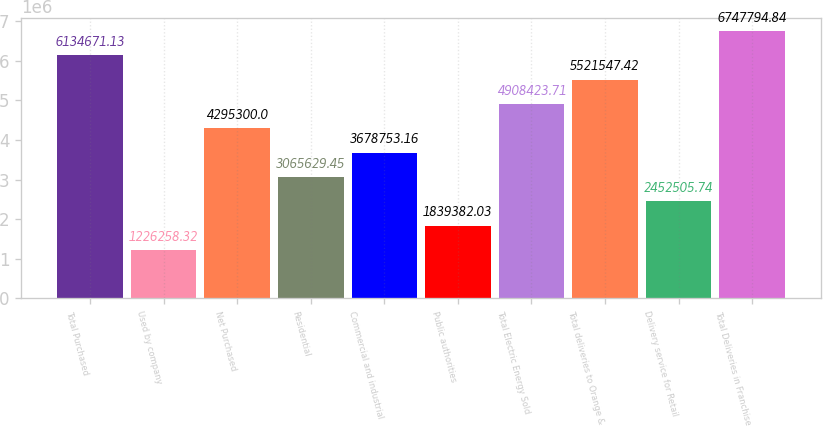Convert chart. <chart><loc_0><loc_0><loc_500><loc_500><bar_chart><fcel>Total Purchased<fcel>Used by company<fcel>Net Purchased<fcel>Residential<fcel>Commercial and industrial<fcel>Public authorities<fcel>Total Electric Energy Sold<fcel>Total deliveries to Orange &<fcel>Delivery service for Retail<fcel>Total Deliveries in Franchise<nl><fcel>6.13467e+06<fcel>1.22626e+06<fcel>4.2953e+06<fcel>3.06563e+06<fcel>3.67875e+06<fcel>1.83938e+06<fcel>4.90842e+06<fcel>5.52155e+06<fcel>2.45251e+06<fcel>6.74779e+06<nl></chart> 